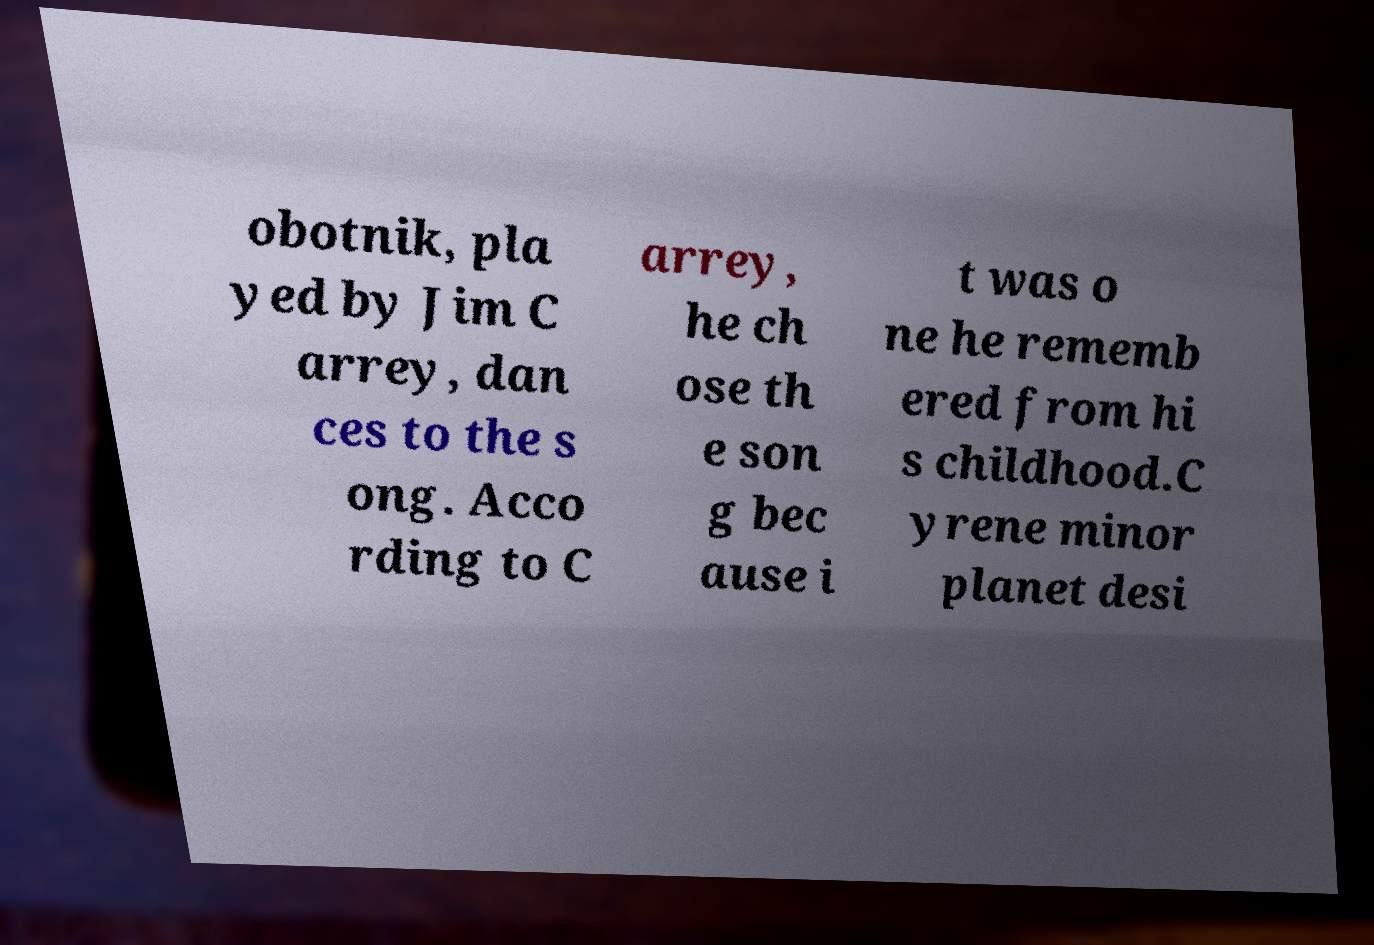I need the written content from this picture converted into text. Can you do that? obotnik, pla yed by Jim C arrey, dan ces to the s ong. Acco rding to C arrey, he ch ose th e son g bec ause i t was o ne he rememb ered from hi s childhood.C yrene minor planet desi 